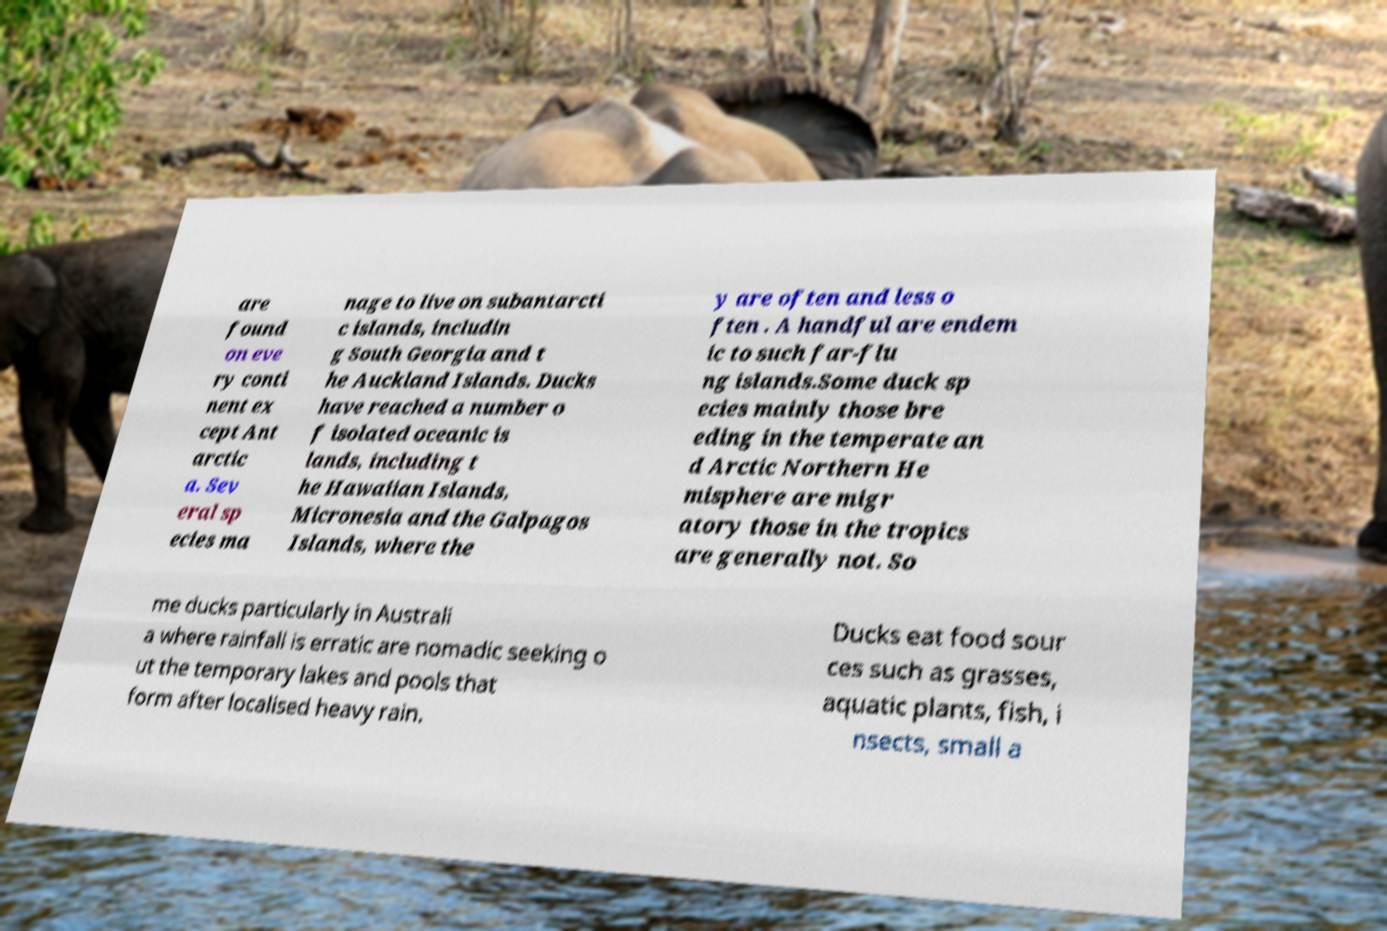Please read and relay the text visible in this image. What does it say? are found on eve ry conti nent ex cept Ant arctic a. Sev eral sp ecies ma nage to live on subantarcti c islands, includin g South Georgia and t he Auckland Islands. Ducks have reached a number o f isolated oceanic is lands, including t he Hawaiian Islands, Micronesia and the Galpagos Islands, where the y are often and less o ften . A handful are endem ic to such far-flu ng islands.Some duck sp ecies mainly those bre eding in the temperate an d Arctic Northern He misphere are migr atory those in the tropics are generally not. So me ducks particularly in Australi a where rainfall is erratic are nomadic seeking o ut the temporary lakes and pools that form after localised heavy rain. Ducks eat food sour ces such as grasses, aquatic plants, fish, i nsects, small a 